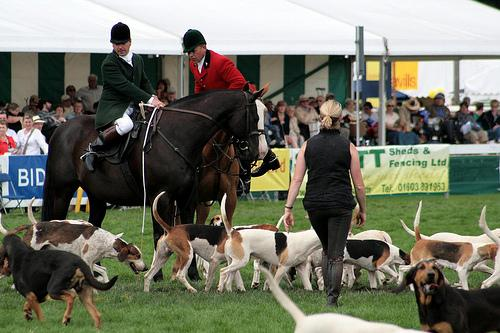Count the total number of dogs visible in the image. There are many dogs visible, including a black hunting dog, a black and brown dog, and several beagles. Describe an object in the image related to equestrian events. There is part of an equestrian event visible with riders wearing different colored jackets and riding horses. What colors can be seen on the beagles in the image? The beagles are typically white, brown, and black. Choose two people in the image and describe their clothing. One rider is wearing a forest green jacket, and another rider has on a red coat. What are the spectators doing in the image? Spectators are watching a dog show, gathering for the beginning of the hunt, and observing riders and dogs. Identify the key event taking place in the image. A group of hunters and beagles are assembling for a fox hunt on a lawn with spectators watching. Explain the scene with the advertisement in the image. There is a yellow and green advertisement for the big hunt on a fence with green letters on the side of a yellow banner. Which animal is mentioned as participating in the hunt? Bloodhound and beagles are mentioned as participating in the hunt. Describe a specific interaction between a person and an animal in the image. A man is propping himself on a horse, preparing to mount his steed for the hunt. Describe the appearance of the woman with blonde hair in the image. The woman has blonde hair, and she is wearing a black vest, a black shirt, black pants, and a bracelet. 